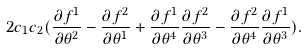Convert formula to latex. <formula><loc_0><loc_0><loc_500><loc_500>2 c _ { 1 } c _ { 2 } ( \frac { \partial f ^ { 1 } } { \partial \theta ^ { 2 } } - \frac { \partial f ^ { 2 } } { \partial \theta ^ { 1 } } + \frac { \partial f ^ { 1 } } { \partial \theta ^ { 4 } } \frac { \partial f ^ { 2 } } { \partial \theta ^ { 3 } } - \frac { \partial f ^ { 2 } } { \partial \theta ^ { 4 } } \frac { \partial f ^ { 1 } } { \partial \theta ^ { 3 } } ) .</formula> 